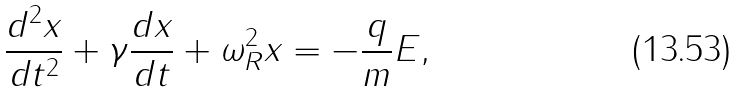<formula> <loc_0><loc_0><loc_500><loc_500>\frac { d ^ { 2 } { x } } { d t ^ { 2 } } + \gamma \frac { d { x } } { d t } + \omega _ { R } ^ { 2 } { x } = - \frac { q } { m } { E } ,</formula> 